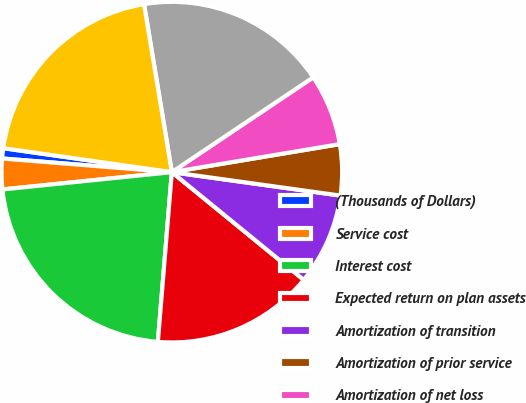Convert chart. <chart><loc_0><loc_0><loc_500><loc_500><pie_chart><fcel>(Thousands of Dollars)<fcel>Service cost<fcel>Interest cost<fcel>Expected return on plan assets<fcel>Amortization of transition<fcel>Amortization of prior service<fcel>Amortization of net loss<fcel>Net periodic postretirement<fcel>Net benefit cost recognized<nl><fcel>0.97%<fcel>2.9%<fcel>22.07%<fcel>15.41%<fcel>8.7%<fcel>4.83%<fcel>6.77%<fcel>18.21%<fcel>20.14%<nl></chart> 